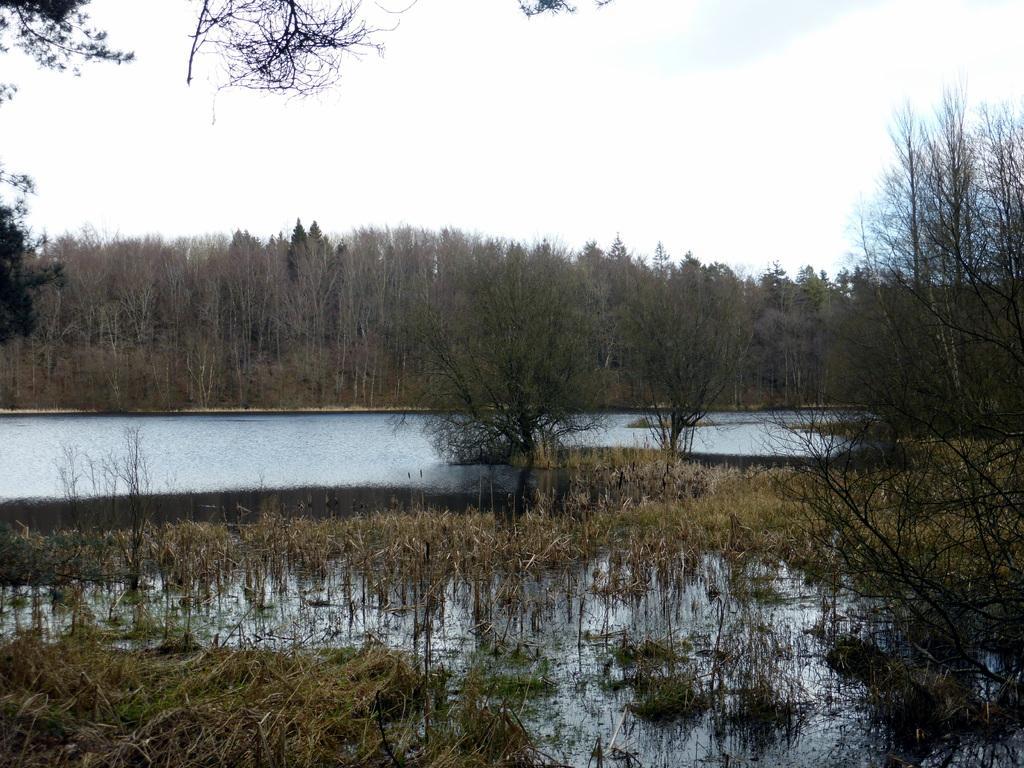Can you describe this image briefly? In this image, there is an outside view. There is a lake in between trees. There is a sky at the top of the image. 